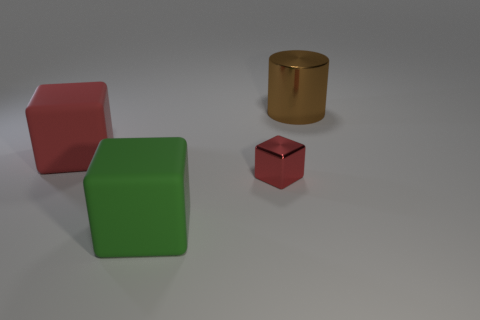Add 2 large green cubes. How many objects exist? 6 Subtract all blocks. How many objects are left? 1 Add 2 green matte cubes. How many green matte cubes are left? 3 Add 3 big purple rubber things. How many big purple rubber things exist? 3 Subtract 0 blue cubes. How many objects are left? 4 Subtract all large shiny cylinders. Subtract all big matte blocks. How many objects are left? 1 